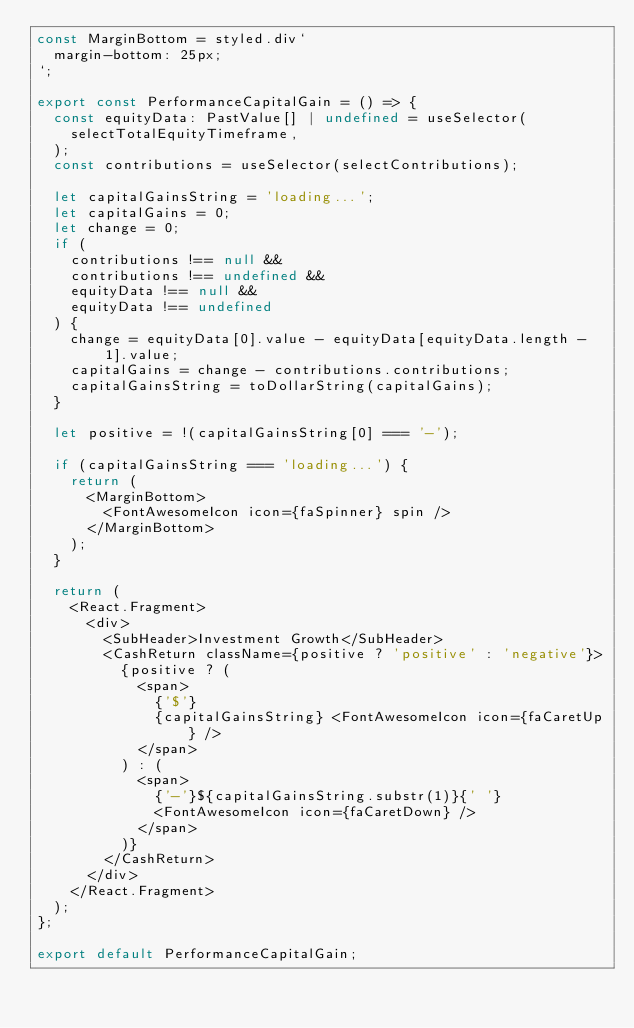<code> <loc_0><loc_0><loc_500><loc_500><_TypeScript_>const MarginBottom = styled.div`
  margin-bottom: 25px;
`;

export const PerformanceCapitalGain = () => {
  const equityData: PastValue[] | undefined = useSelector(
    selectTotalEquityTimeframe,
  );
  const contributions = useSelector(selectContributions);

  let capitalGainsString = 'loading...';
  let capitalGains = 0;
  let change = 0;
  if (
    contributions !== null &&
    contributions !== undefined &&
    equityData !== null &&
    equityData !== undefined
  ) {
    change = equityData[0].value - equityData[equityData.length - 1].value;
    capitalGains = change - contributions.contributions;
    capitalGainsString = toDollarString(capitalGains);
  }

  let positive = !(capitalGainsString[0] === '-');

  if (capitalGainsString === 'loading...') {
    return (
      <MarginBottom>
        <FontAwesomeIcon icon={faSpinner} spin />
      </MarginBottom>
    );
  }

  return (
    <React.Fragment>
      <div>
        <SubHeader>Investment Growth</SubHeader>
        <CashReturn className={positive ? 'positive' : 'negative'}>
          {positive ? (
            <span>
              {'$'}
              {capitalGainsString} <FontAwesomeIcon icon={faCaretUp} />
            </span>
          ) : (
            <span>
              {'-'}${capitalGainsString.substr(1)}{' '}
              <FontAwesomeIcon icon={faCaretDown} />
            </span>
          )}
        </CashReturn>
      </div>
    </React.Fragment>
  );
};

export default PerformanceCapitalGain;
</code> 